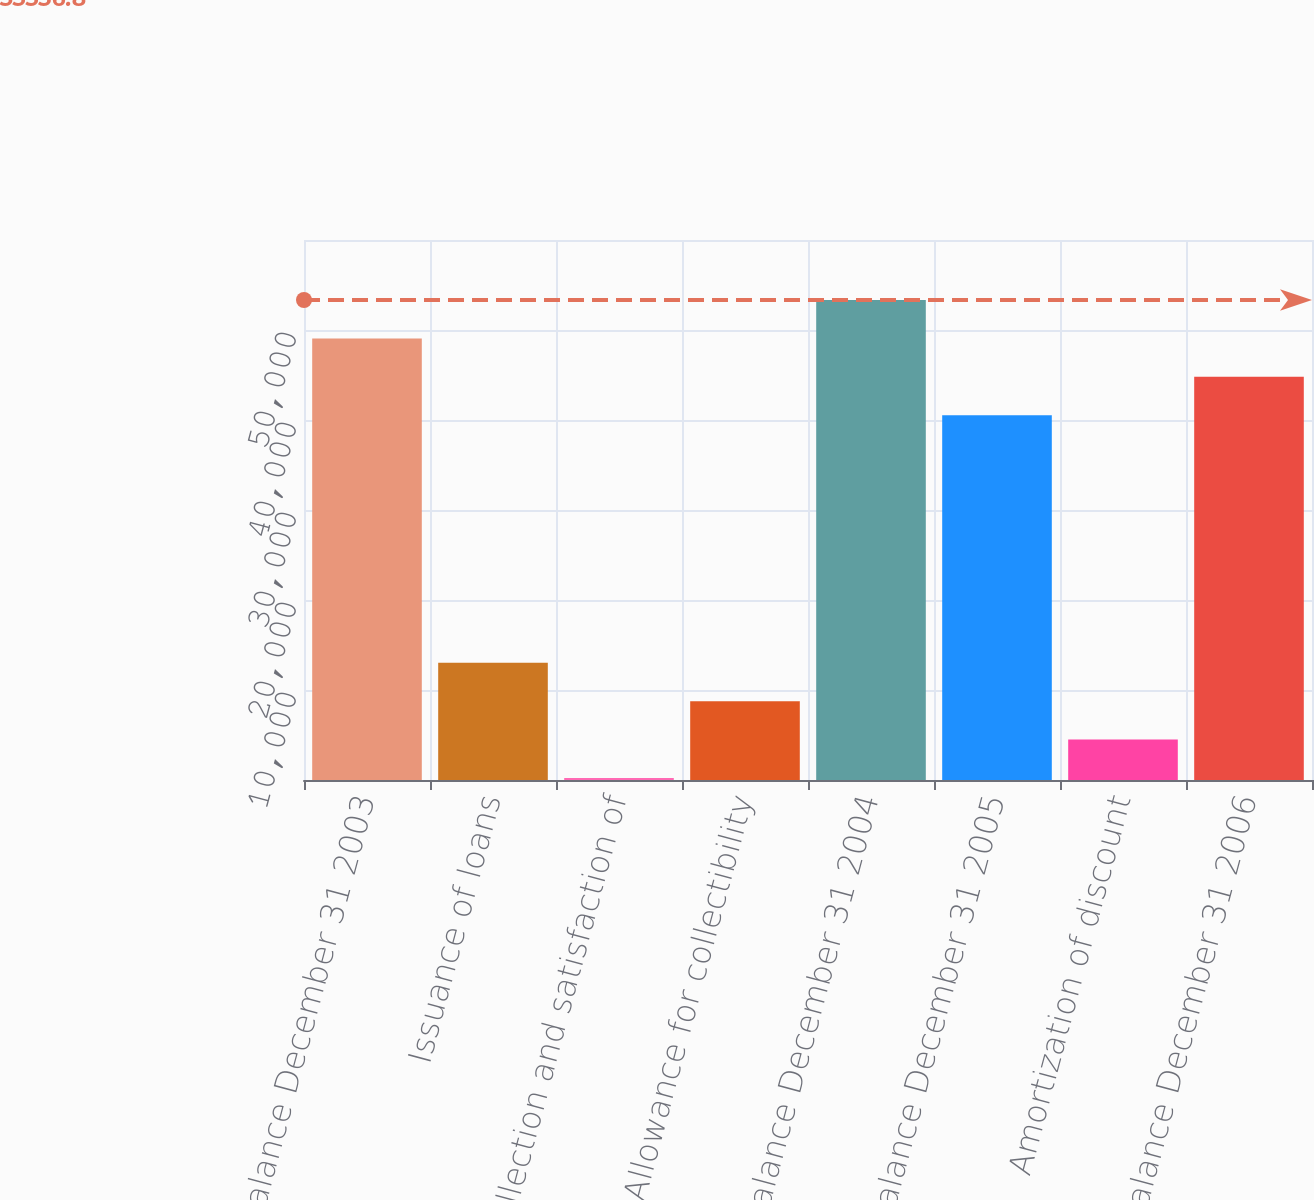Convert chart. <chart><loc_0><loc_0><loc_500><loc_500><bar_chart><fcel>Balance December 31 2003<fcel>Issuance of loans<fcel>Collection and satisfaction of<fcel>Allowance for collectibility<fcel>Balance December 31 2004<fcel>Balance December 31 2005<fcel>Amortization of discount<fcel>Balance December 31 2006<nl><fcel>49068.2<fcel>13028.8<fcel>223<fcel>8760.2<fcel>53336.8<fcel>40531<fcel>4491.6<fcel>44799.6<nl></chart> 